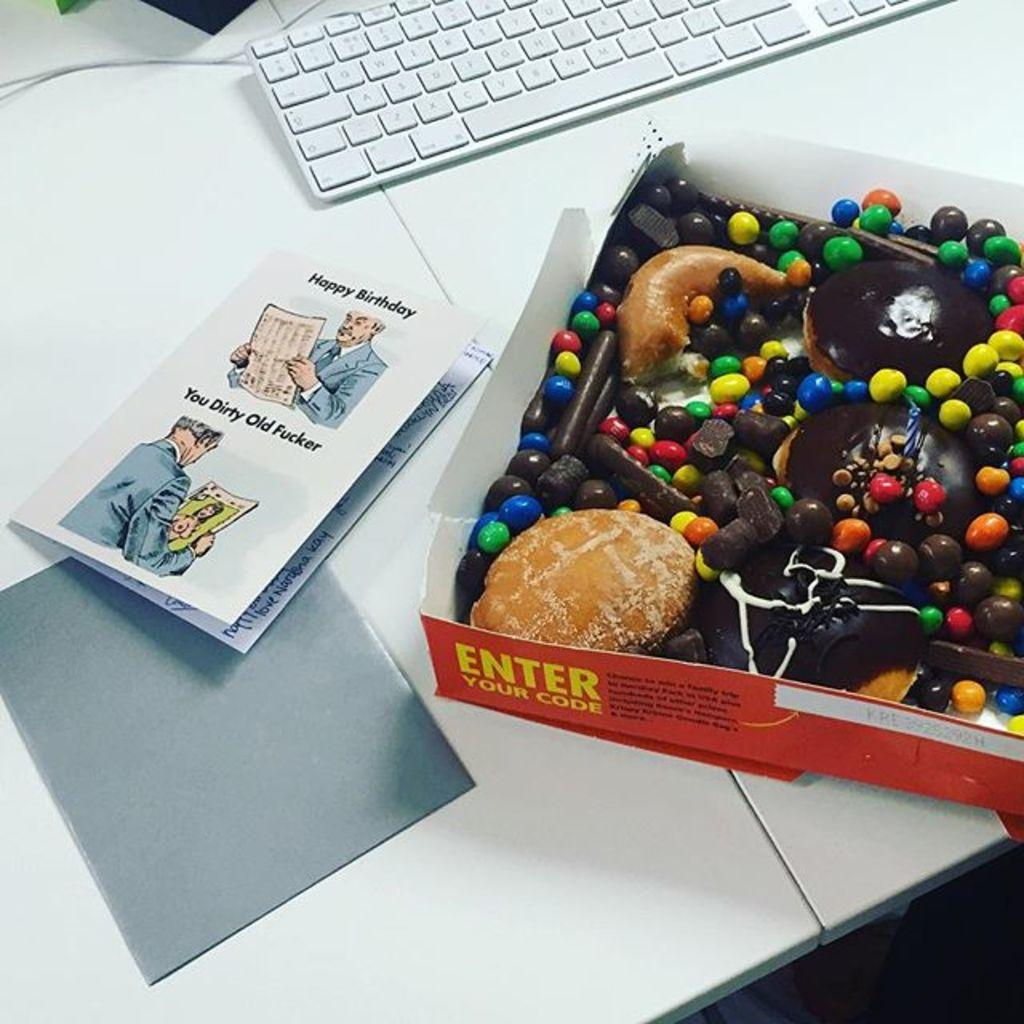<image>
Share a concise interpretation of the image provided. A funny Happy Birthday card sits next to a box of donuts and candy 